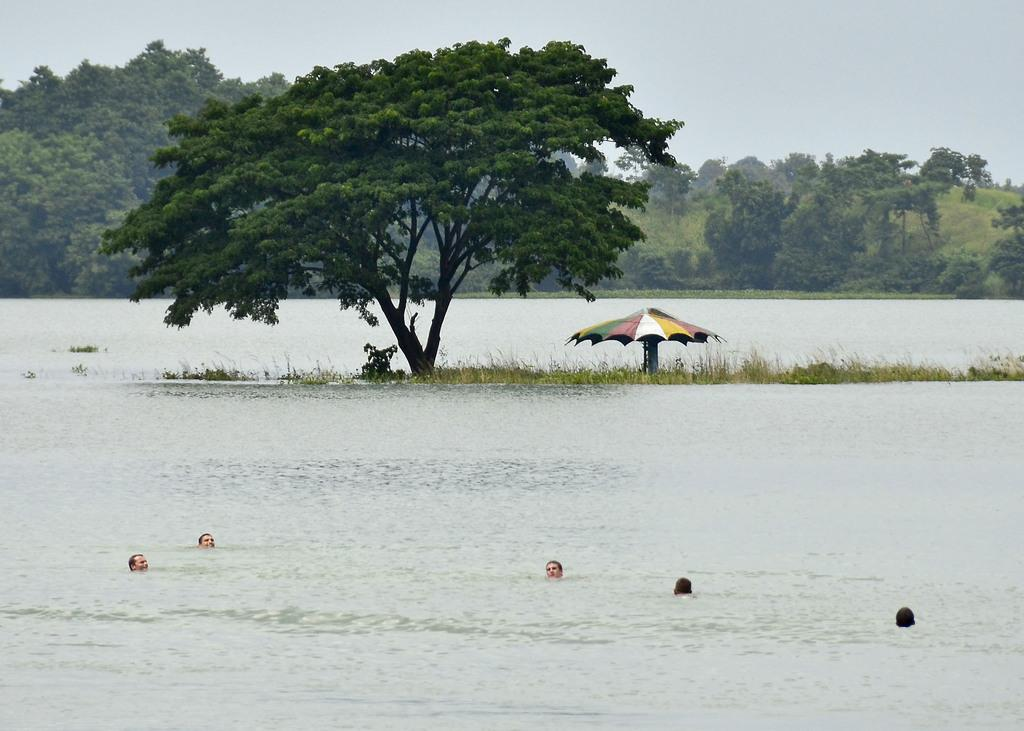What is one of the natural elements present in the image? There is water in the image. What object can be seen in the image that might provide shade or protection from the rain? There is an umbrella in the image. What type of terrain is visible in the image? There is grass in the image. How many people are present in the image? There are people in the image. What type of vegetation can be seen in the image? There are trees in the image. What part of the environment is visible in the image? The sky is visible in the image. Can you see any rabbits using a fork to eat in the image? There are no rabbits or forks present in the image. Is there any indication that something is burning in the image? There is no indication of anything burning in the image. 